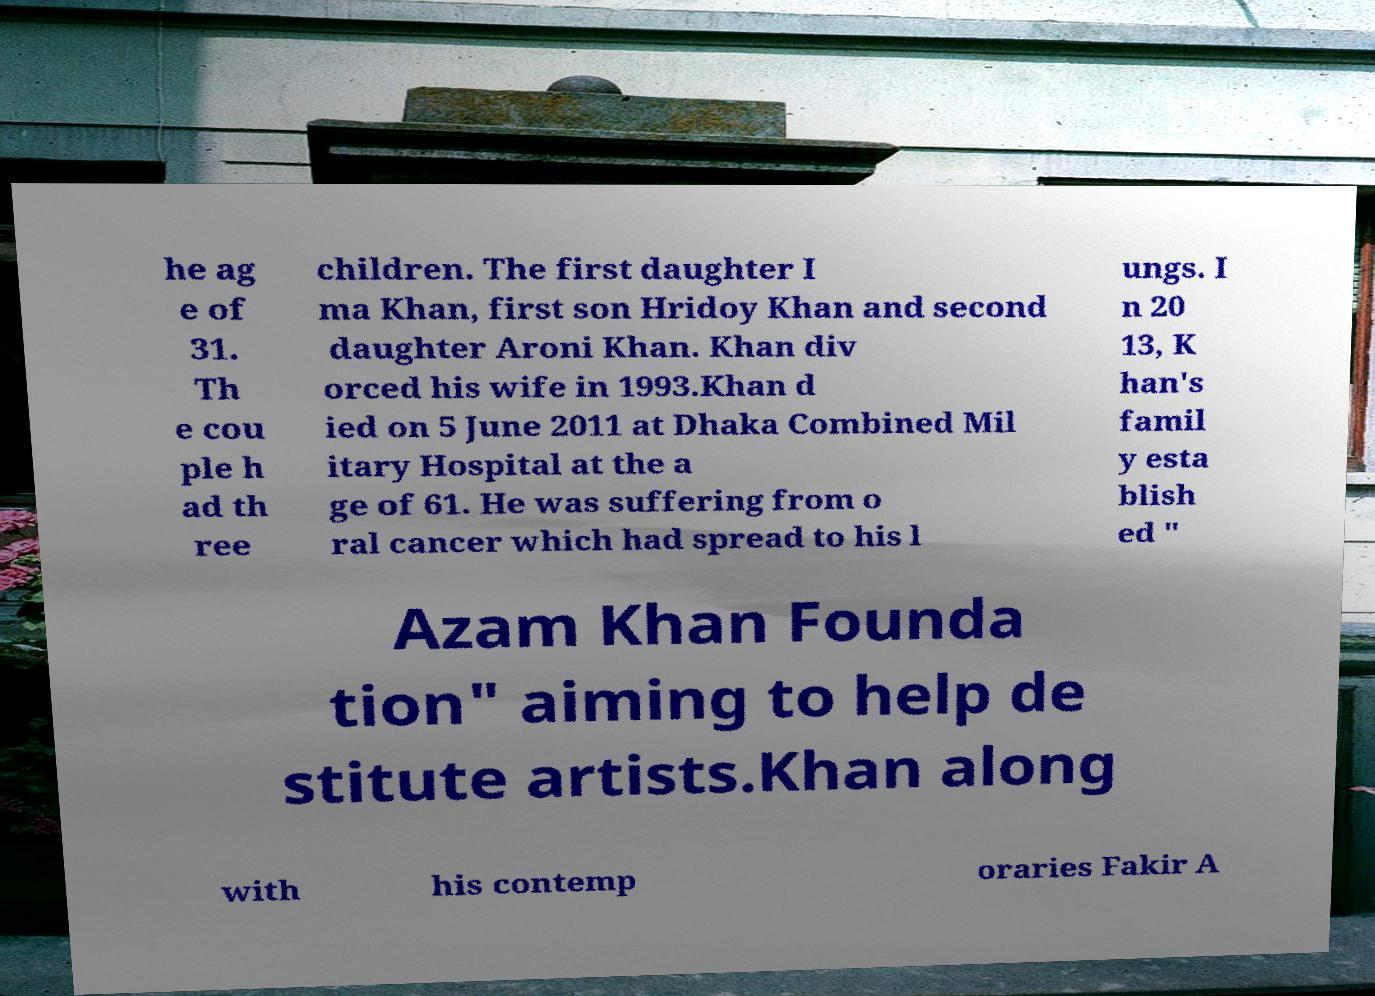Can you accurately transcribe the text from the provided image for me? he ag e of 31. Th e cou ple h ad th ree children. The first daughter I ma Khan, first son Hridoy Khan and second daughter Aroni Khan. Khan div orced his wife in 1993.Khan d ied on 5 June 2011 at Dhaka Combined Mil itary Hospital at the a ge of 61. He was suffering from o ral cancer which had spread to his l ungs. I n 20 13, K han's famil y esta blish ed " Azam Khan Founda tion" aiming to help de stitute artists.Khan along with his contemp oraries Fakir A 